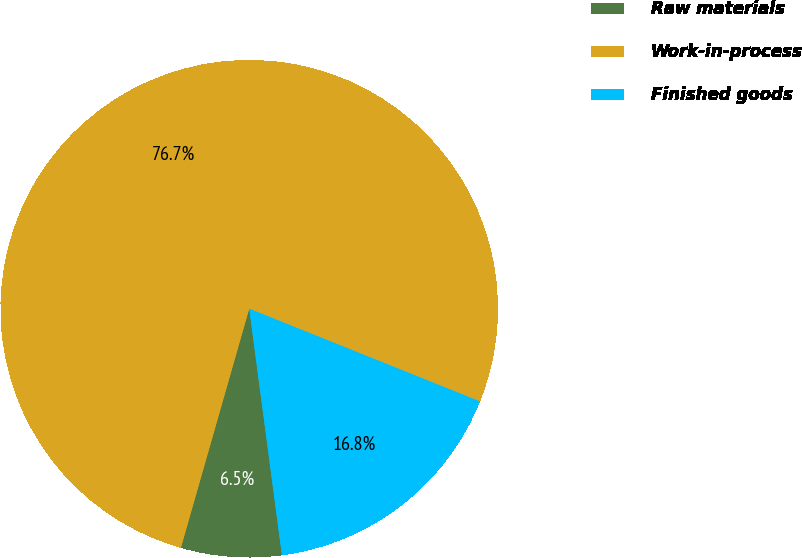<chart> <loc_0><loc_0><loc_500><loc_500><pie_chart><fcel>Raw materials<fcel>Work-in-process<fcel>Finished goods<nl><fcel>6.53%<fcel>76.65%<fcel>16.82%<nl></chart> 